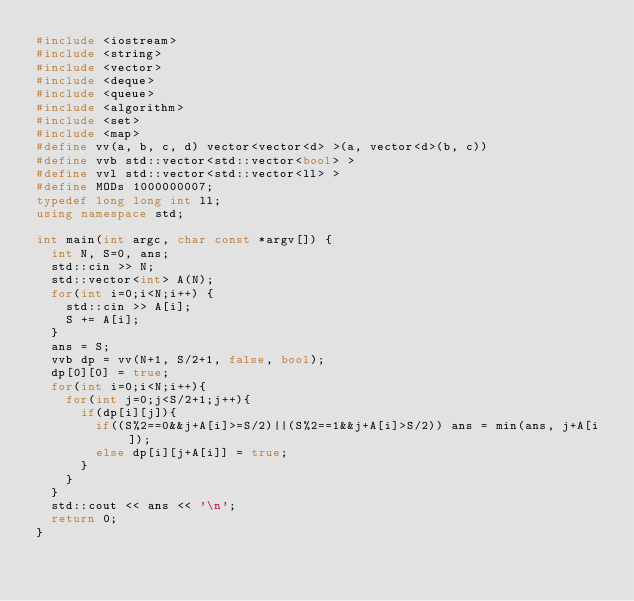<code> <loc_0><loc_0><loc_500><loc_500><_C++_>#include <iostream>
#include <string>
#include <vector>
#include <deque>
#include <queue>
#include <algorithm>
#include <set>
#include <map>
#define vv(a, b, c, d) vector<vector<d> >(a, vector<d>(b, c))
#define vvb std::vector<std::vector<bool> >
#define vvl std::vector<std::vector<ll> >
#define MODs 1000000007;
typedef long long int ll;
using namespace std;

int main(int argc, char const *argv[]) {
  int N, S=0, ans;
  std::cin >> N;
  std::vector<int> A(N);
  for(int i=0;i<N;i++) {
    std::cin >> A[i];
    S += A[i];
  }
  ans = S;
  vvb dp = vv(N+1, S/2+1, false, bool);
  dp[0][0] = true;
  for(int i=0;i<N;i++){
    for(int j=0;j<S/2+1;j++){
      if(dp[i][j]){
        if((S%2==0&&j+A[i]>=S/2)||(S%2==1&&j+A[i]>S/2)) ans = min(ans, j+A[i]);
        else dp[i][j+A[i]] = true;
      }
    }
  }
  std::cout << ans << '\n';
  return 0;
}
</code> 